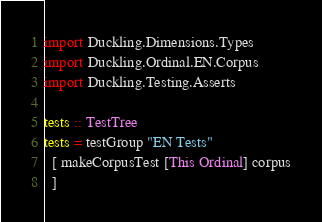<code> <loc_0><loc_0><loc_500><loc_500><_Haskell_>import Duckling.Dimensions.Types
import Duckling.Ordinal.EN.Corpus
import Duckling.Testing.Asserts

tests :: TestTree
tests = testGroup "EN Tests"
  [ makeCorpusTest [This Ordinal] corpus
  ]
</code> 